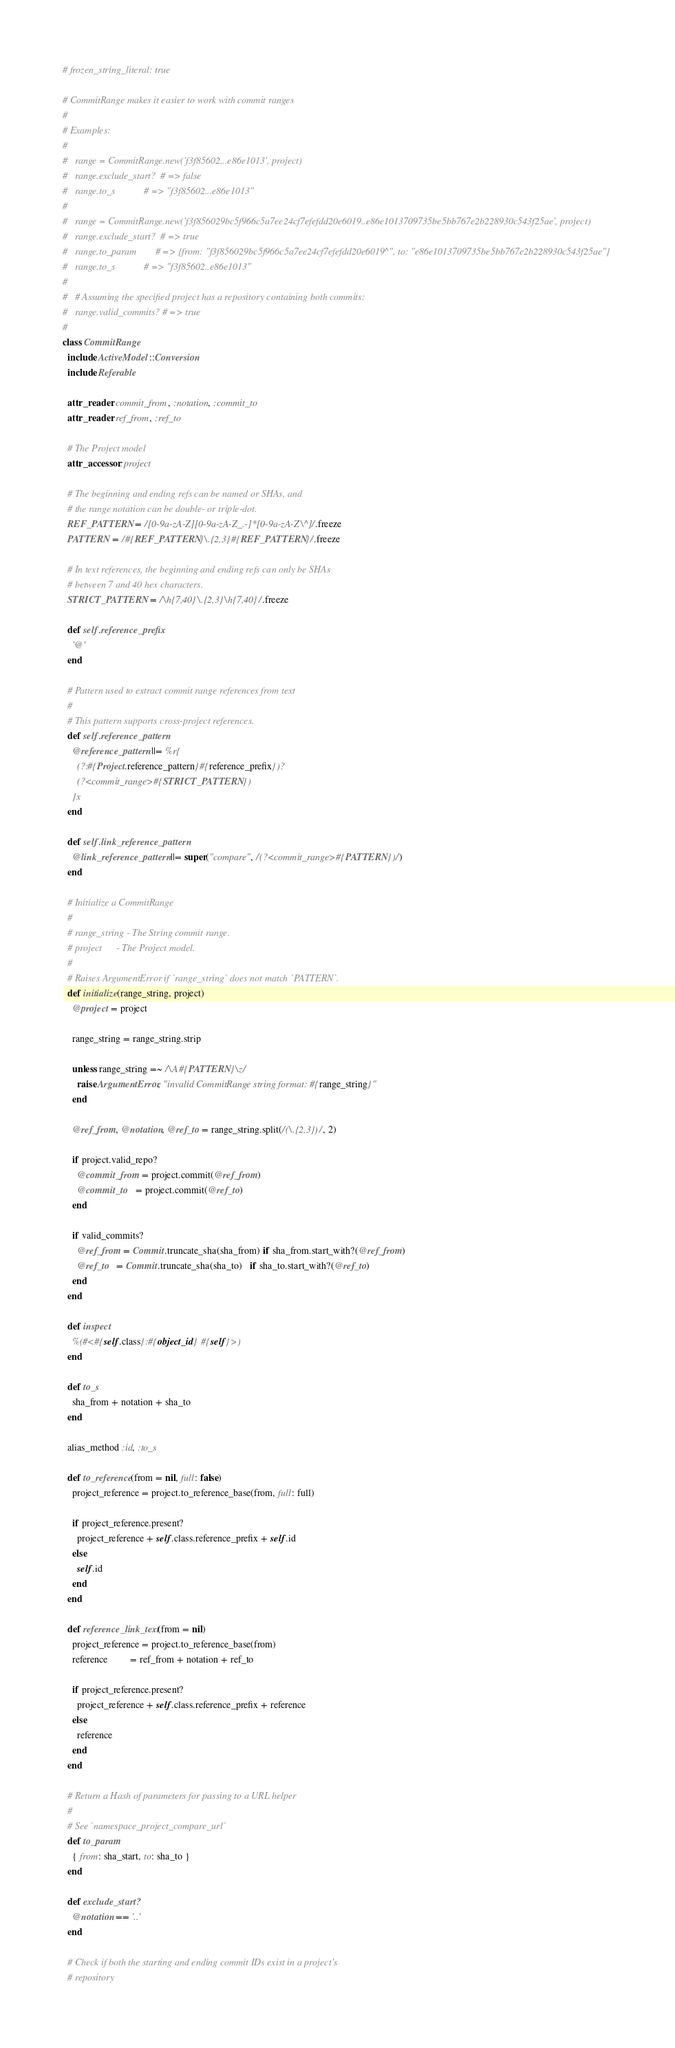<code> <loc_0><loc_0><loc_500><loc_500><_Ruby_># frozen_string_literal: true

# CommitRange makes it easier to work with commit ranges
#
# Examples:
#
#   range = CommitRange.new('f3f85602...e86e1013', project)
#   range.exclude_start?  # => false
#   range.to_s            # => "f3f85602...e86e1013"
#
#   range = CommitRange.new('f3f856029bc5f966c5a7ee24cf7efefdd20e6019..e86e1013709735be5bb767e2b228930c543f25ae', project)
#   range.exclude_start?  # => true
#   range.to_param        # => {from: "f3f856029bc5f966c5a7ee24cf7efefdd20e6019^", to: "e86e1013709735be5bb767e2b228930c543f25ae"}
#   range.to_s            # => "f3f85602..e86e1013"
#
#   # Assuming the specified project has a repository containing both commits:
#   range.valid_commits? # => true
#
class CommitRange
  include ActiveModel::Conversion
  include Referable

  attr_reader :commit_from, :notation, :commit_to
  attr_reader :ref_from, :ref_to

  # The Project model
  attr_accessor :project

  # The beginning and ending refs can be named or SHAs, and
  # the range notation can be double- or triple-dot.
  REF_PATTERN = /[0-9a-zA-Z][0-9a-zA-Z_.-]*[0-9a-zA-Z\^]/.freeze
  PATTERN = /#{REF_PATTERN}\.{2,3}#{REF_PATTERN}/.freeze

  # In text references, the beginning and ending refs can only be SHAs
  # between 7 and 40 hex characters.
  STRICT_PATTERN = /\h{7,40}\.{2,3}\h{7,40}/.freeze

  def self.reference_prefix
    '@'
  end

  # Pattern used to extract commit range references from text
  #
  # This pattern supports cross-project references.
  def self.reference_pattern
    @reference_pattern ||= %r{
      (?:#{Project.reference_pattern}#{reference_prefix})?
      (?<commit_range>#{STRICT_PATTERN})
    }x
  end

  def self.link_reference_pattern
    @link_reference_pattern ||= super("compare", /(?<commit_range>#{PATTERN})/)
  end

  # Initialize a CommitRange
  #
  # range_string - The String commit range.
  # project      - The Project model.
  #
  # Raises ArgumentError if `range_string` does not match `PATTERN`.
  def initialize(range_string, project)
    @project = project

    range_string = range_string.strip

    unless range_string =~ /\A#{PATTERN}\z/
      raise ArgumentError, "invalid CommitRange string format: #{range_string}"
    end

    @ref_from, @notation, @ref_to = range_string.split(/(\.{2,3})/, 2)

    if project.valid_repo?
      @commit_from = project.commit(@ref_from)
      @commit_to   = project.commit(@ref_to)
    end

    if valid_commits?
      @ref_from = Commit.truncate_sha(sha_from) if sha_from.start_with?(@ref_from)
      @ref_to   = Commit.truncate_sha(sha_to)   if sha_to.start_with?(@ref_to)
    end
  end

  def inspect
    %(#<#{self.class}:#{object_id} #{self}>)
  end

  def to_s
    sha_from + notation + sha_to
  end

  alias_method :id, :to_s

  def to_reference(from = nil, full: false)
    project_reference = project.to_reference_base(from, full: full)

    if project_reference.present?
      project_reference + self.class.reference_prefix + self.id
    else
      self.id
    end
  end

  def reference_link_text(from = nil)
    project_reference = project.to_reference_base(from)
    reference         = ref_from + notation + ref_to

    if project_reference.present?
      project_reference + self.class.reference_prefix + reference
    else
      reference
    end
  end

  # Return a Hash of parameters for passing to a URL helper
  #
  # See `namespace_project_compare_url`
  def to_param
    { from: sha_start, to: sha_to }
  end

  def exclude_start?
    @notation == '..'
  end

  # Check if both the starting and ending commit IDs exist in a project's
  # repository</code> 